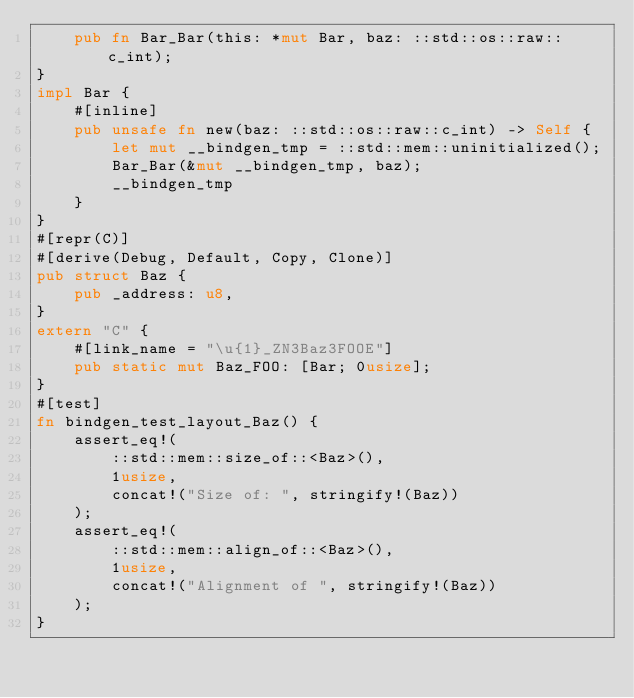Convert code to text. <code><loc_0><loc_0><loc_500><loc_500><_Rust_>    pub fn Bar_Bar(this: *mut Bar, baz: ::std::os::raw::c_int);
}
impl Bar {
    #[inline]
    pub unsafe fn new(baz: ::std::os::raw::c_int) -> Self {
        let mut __bindgen_tmp = ::std::mem::uninitialized();
        Bar_Bar(&mut __bindgen_tmp, baz);
        __bindgen_tmp
    }
}
#[repr(C)]
#[derive(Debug, Default, Copy, Clone)]
pub struct Baz {
    pub _address: u8,
}
extern "C" {
    #[link_name = "\u{1}_ZN3Baz3FOOE"]
    pub static mut Baz_FOO: [Bar; 0usize];
}
#[test]
fn bindgen_test_layout_Baz() {
    assert_eq!(
        ::std::mem::size_of::<Baz>(),
        1usize,
        concat!("Size of: ", stringify!(Baz))
    );
    assert_eq!(
        ::std::mem::align_of::<Baz>(),
        1usize,
        concat!("Alignment of ", stringify!(Baz))
    );
}
</code> 